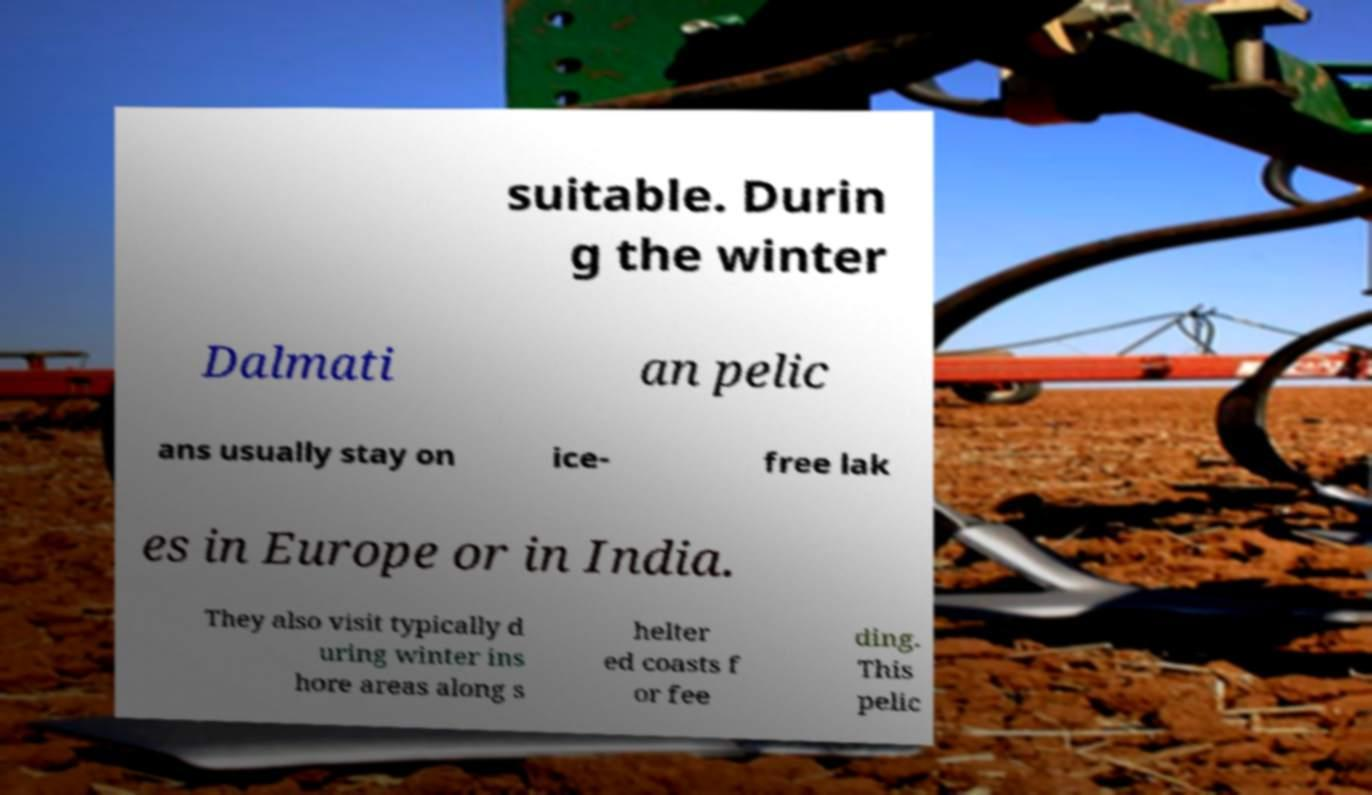Can you read and provide the text displayed in the image?This photo seems to have some interesting text. Can you extract and type it out for me? suitable. Durin g the winter Dalmati an pelic ans usually stay on ice- free lak es in Europe or in India. They also visit typically d uring winter ins hore areas along s helter ed coasts f or fee ding. This pelic 